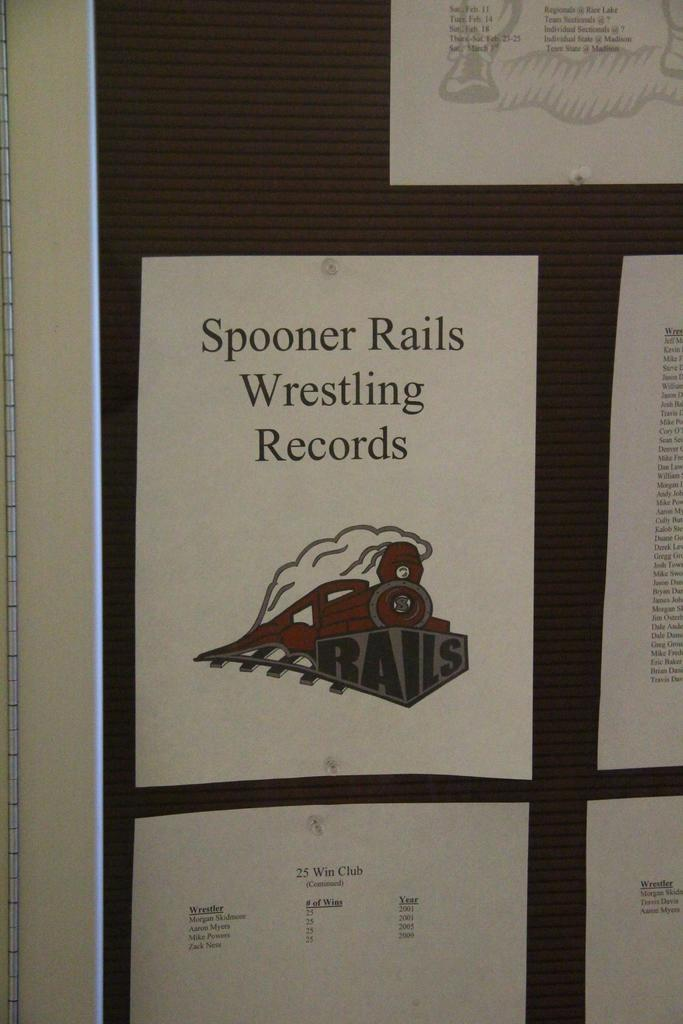<image>
Summarize the visual content of the image. a paper that says 'spooner rails wrestling records' on it 